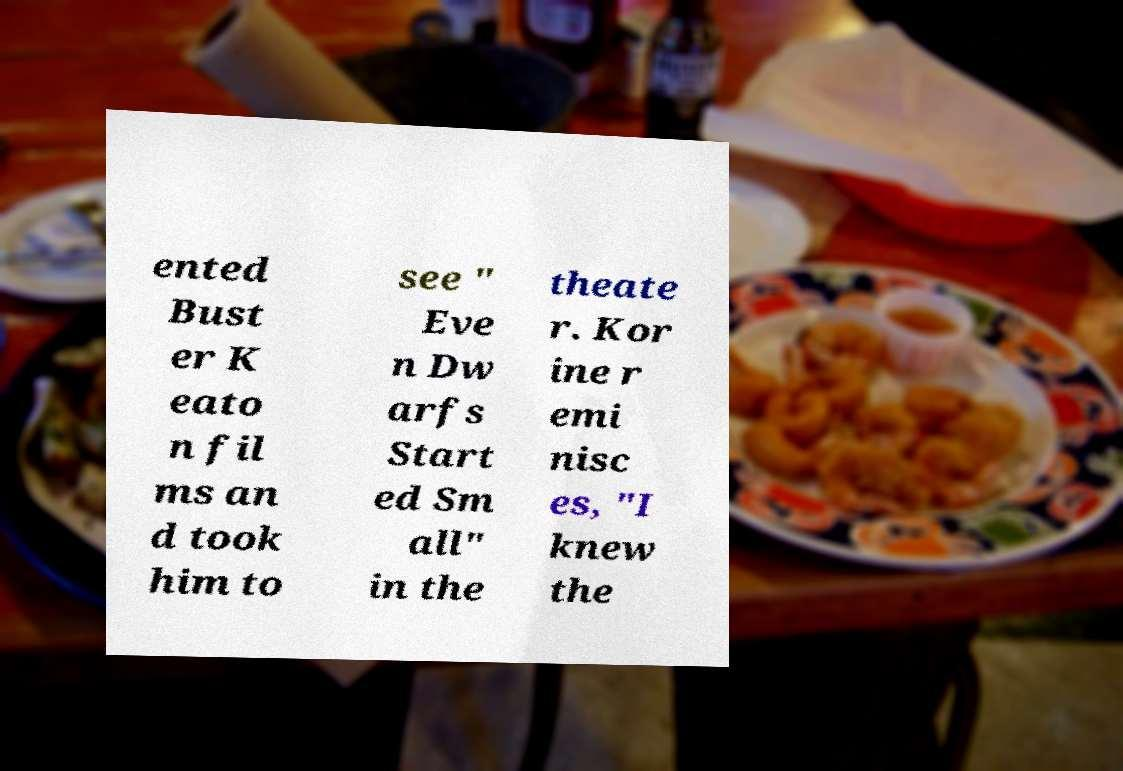There's text embedded in this image that I need extracted. Can you transcribe it verbatim? ented Bust er K eato n fil ms an d took him to see " Eve n Dw arfs Start ed Sm all" in the theate r. Kor ine r emi nisc es, "I knew the 